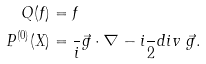<formula> <loc_0><loc_0><loc_500><loc_500>Q ( f ) & = f \\ P ^ { ( 0 ) } ( X ) & = \frac { } { i } \vec { g } \cdot \nabla - i \frac { } { 2 } d i v \ \vec { g } .</formula> 